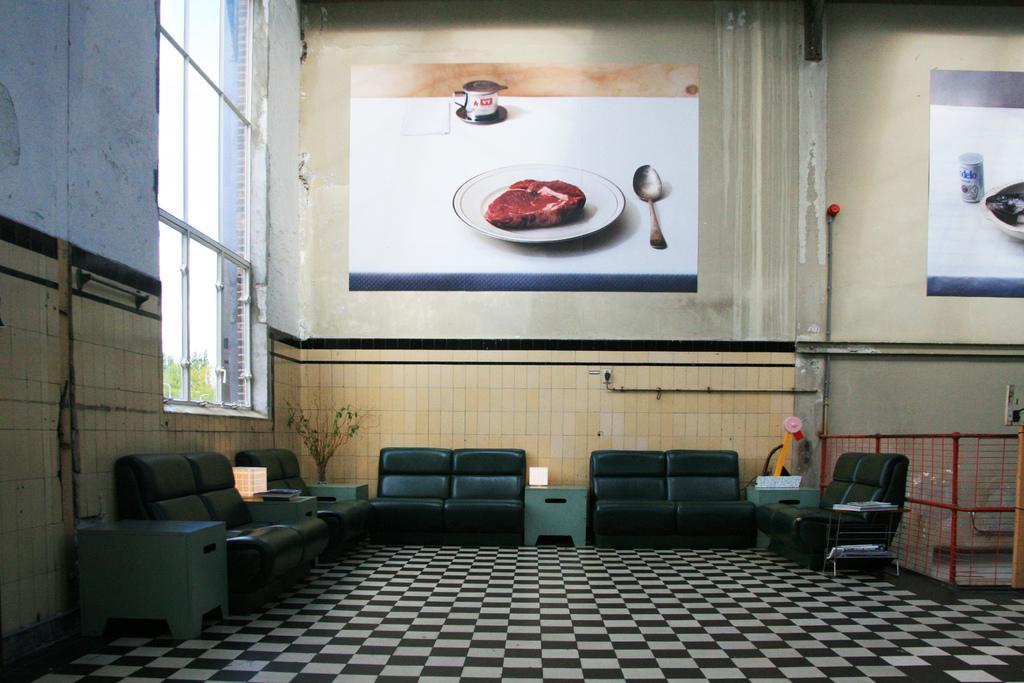Describe this image in one or two sentences. This picture is clicked in a room. Towards the wall there are sofas, tables and a plant. In the left there is a window. To the wall there are two frames, in the center there are plate, spoon, meat and a cup. Towards the right there is another frame with the plate and a can. In the right bottom there is a cage. 